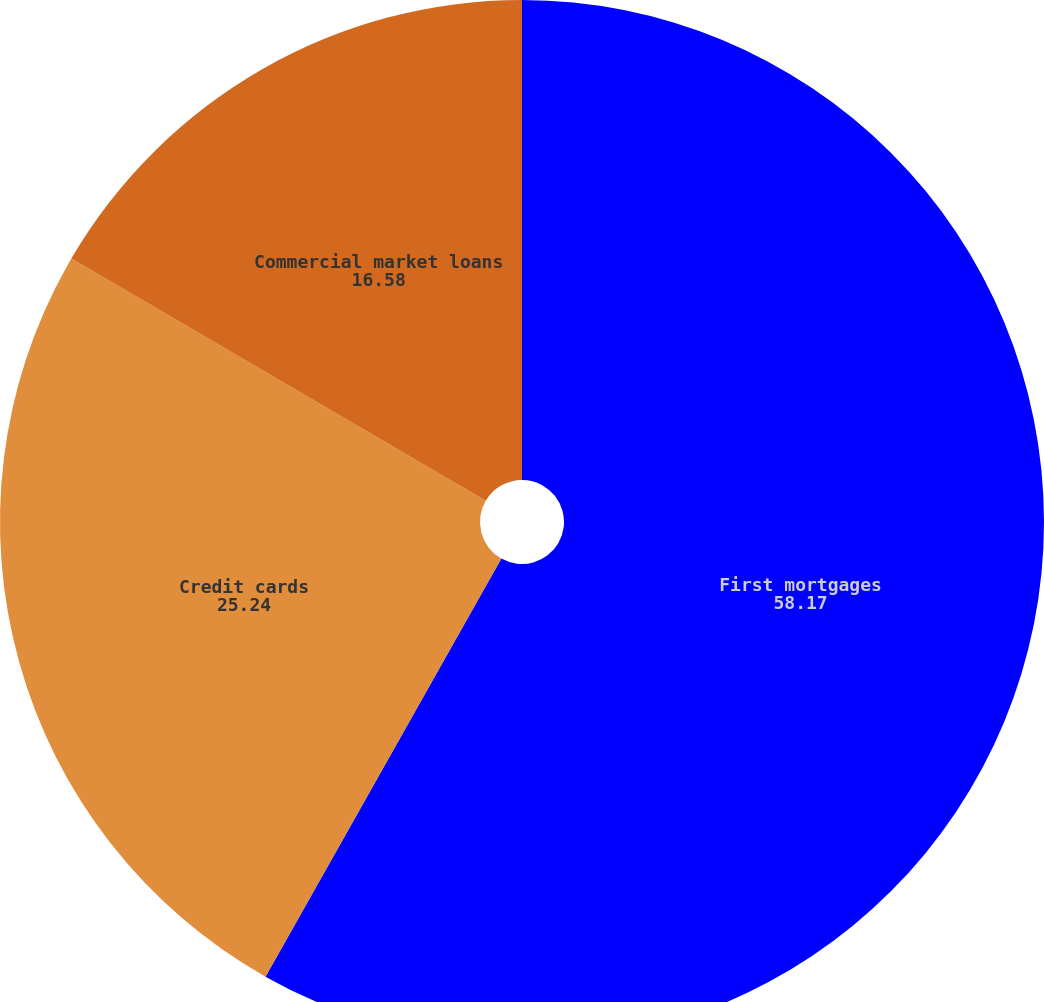<chart> <loc_0><loc_0><loc_500><loc_500><pie_chart><fcel>First mortgages<fcel>Credit cards<fcel>Commercial market loans<nl><fcel>58.17%<fcel>25.24%<fcel>16.58%<nl></chart> 